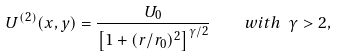Convert formula to latex. <formula><loc_0><loc_0><loc_500><loc_500>U ^ { ( 2 ) } ( x , y ) = \frac { U _ { 0 } } { \left [ 1 + ( r / r _ { 0 } ) ^ { 2 } \right ] ^ { \gamma / 2 } } \quad w i t h \ \gamma > 2 ,</formula> 